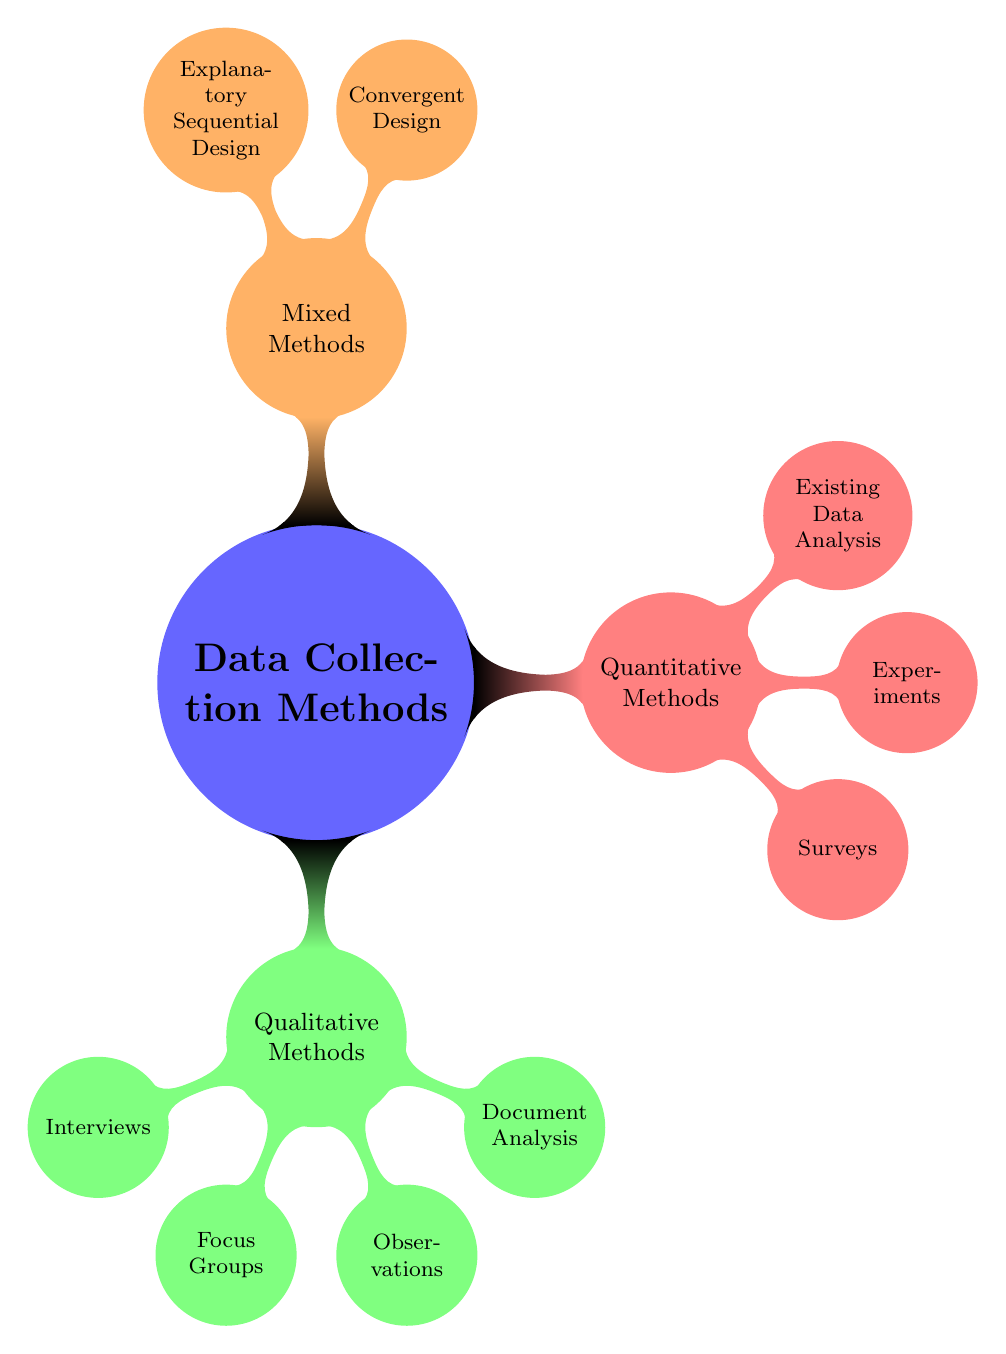What are the three types of qualitative methods shown in the diagram? The diagram lists four nodes under Qualitative Methods, from which three specific nodes related to types are mentioned: Interviews, Focus Groups, and Observations.
Answer: Interviews, Focus Groups, Observations How many quantitative methods are depicted? Under Quantitative Methods, three specific methods are shown: Surveys, Experiments, and Existing Data Analysis. Hence, the count is three.
Answer: 3 What type of design is used in mixed methods for collecting data concurrently? Convergent Design is shown as the node under Mixed Methods that represents concurrent data collection along with data triangulation.
Answer: Convergent Design What is the primary purpose of document analysis within qualitative methods? Document Analysis is included as a qualitative method to analyze various written materials such as policy documents, meeting minutes, and research reports.
Answer: Analyze written materials Which method includes control groups in quantitative research? Control Groups are specifically mentioned under Experiments, which is a category within Quantitative Methods focusing on experimental designs.
Answer: Experiments What are the two designs mentioned under mixed methods? The two designs are Convergent Design and Explanatory Sequential Design as presented under the Mixed Methods section in the diagram.
Answer: Convergent Design, Explanatory Sequential Design Which qualitative method involves facilitating group discussions? Focus Groups are indicated as the qualitative method that involves leaders guiding discussions among a group of participants.
Answer: Focus Groups How many main categories of data collection methods are identified in the mind map? The diagram illustrates three main categories of data collection methods: Qualitative Methods, Quantitative Methods, and Mixed Methods. Thus, the total is three.
Answer: 3 